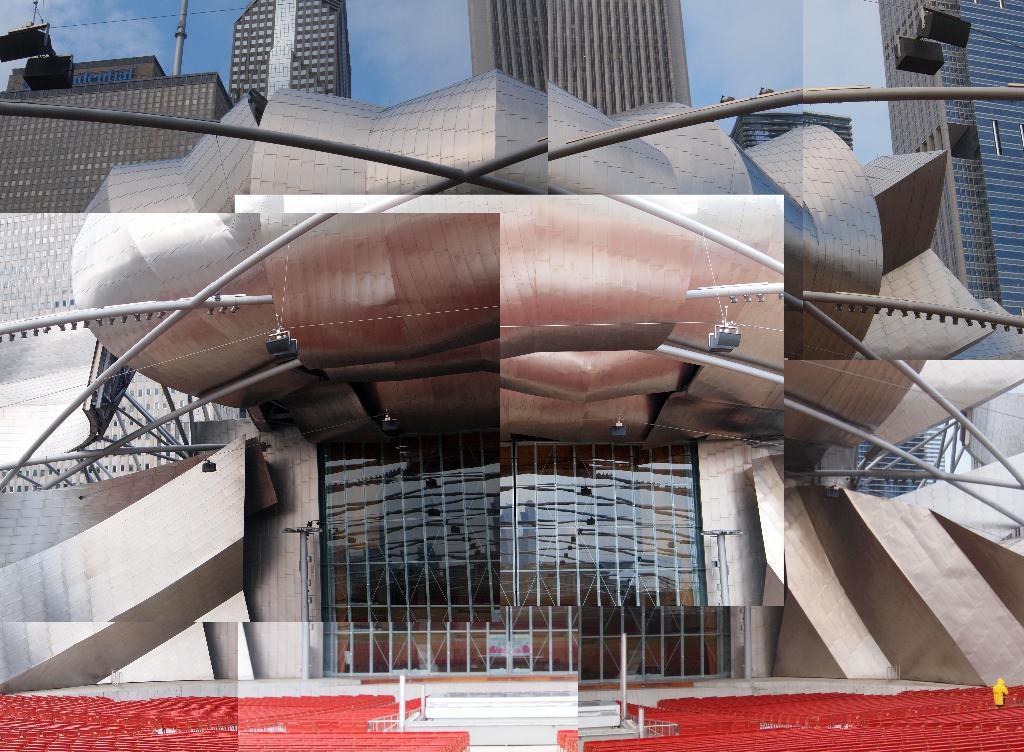Could you give a brief overview of what you see in this image? In this image there is a building in flower structure. Behind it there are few buildings. Top of image there is sky. Left top there are few lights attached to the wire. 